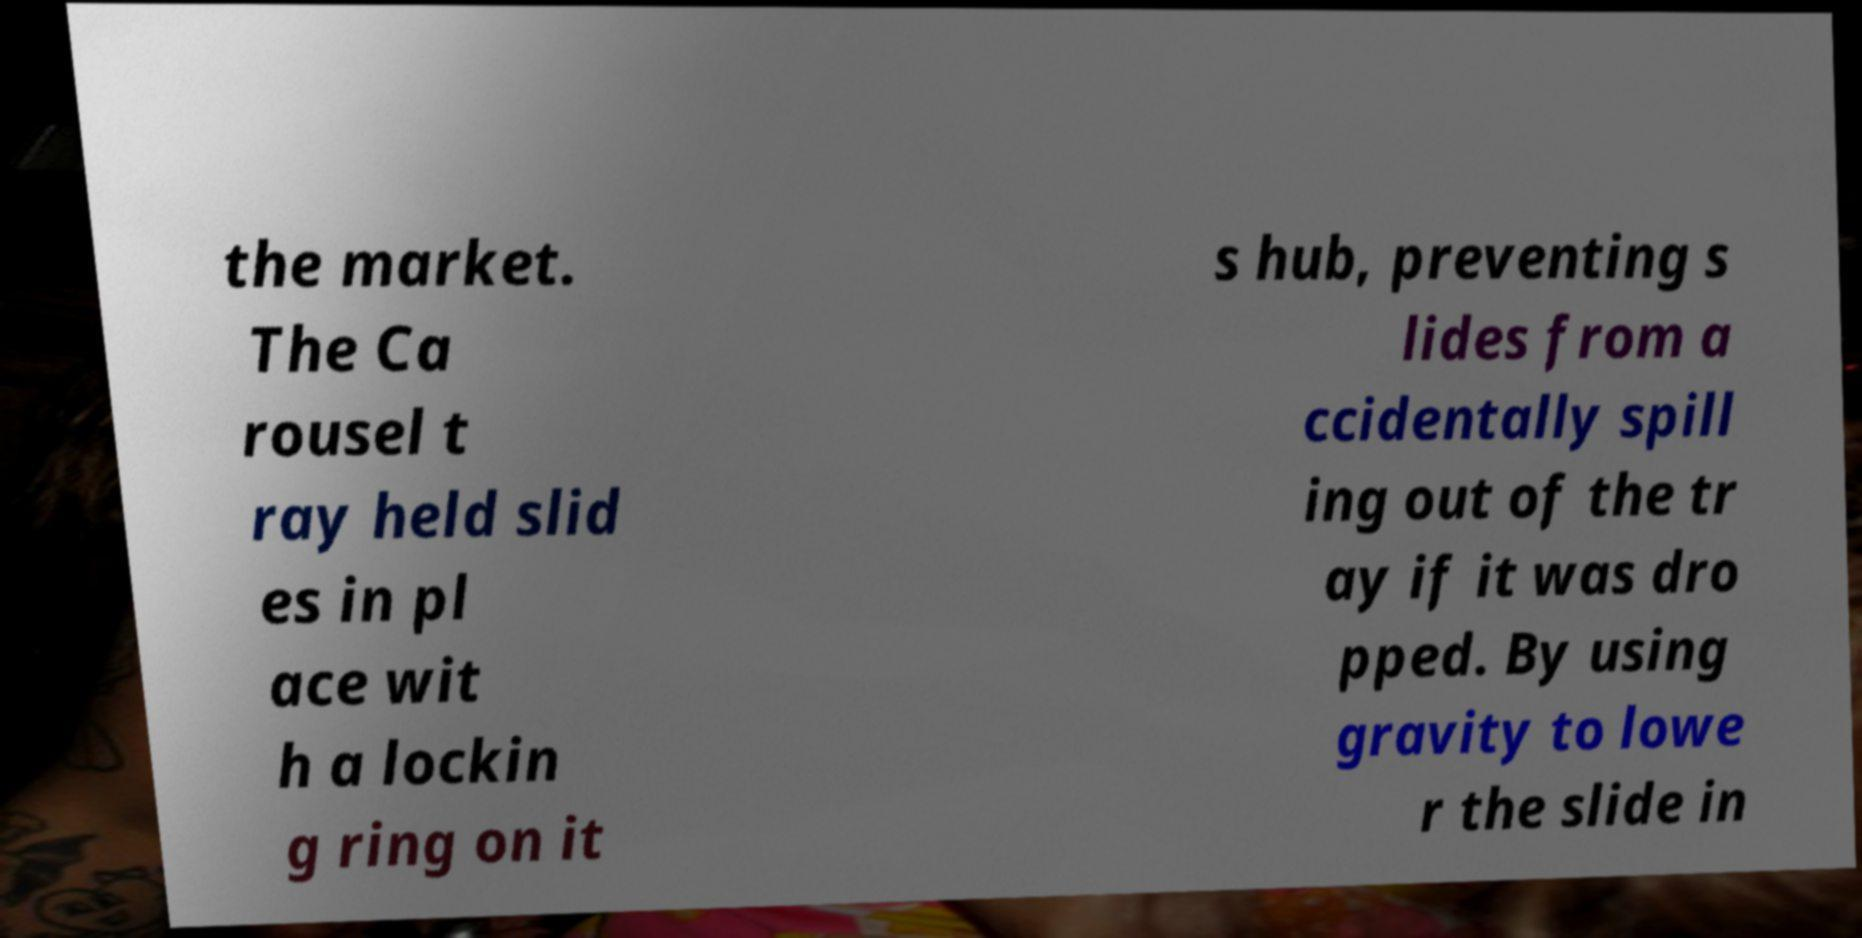I need the written content from this picture converted into text. Can you do that? the market. The Ca rousel t ray held slid es in pl ace wit h a lockin g ring on it s hub, preventing s lides from a ccidentally spill ing out of the tr ay if it was dro pped. By using gravity to lowe r the slide in 